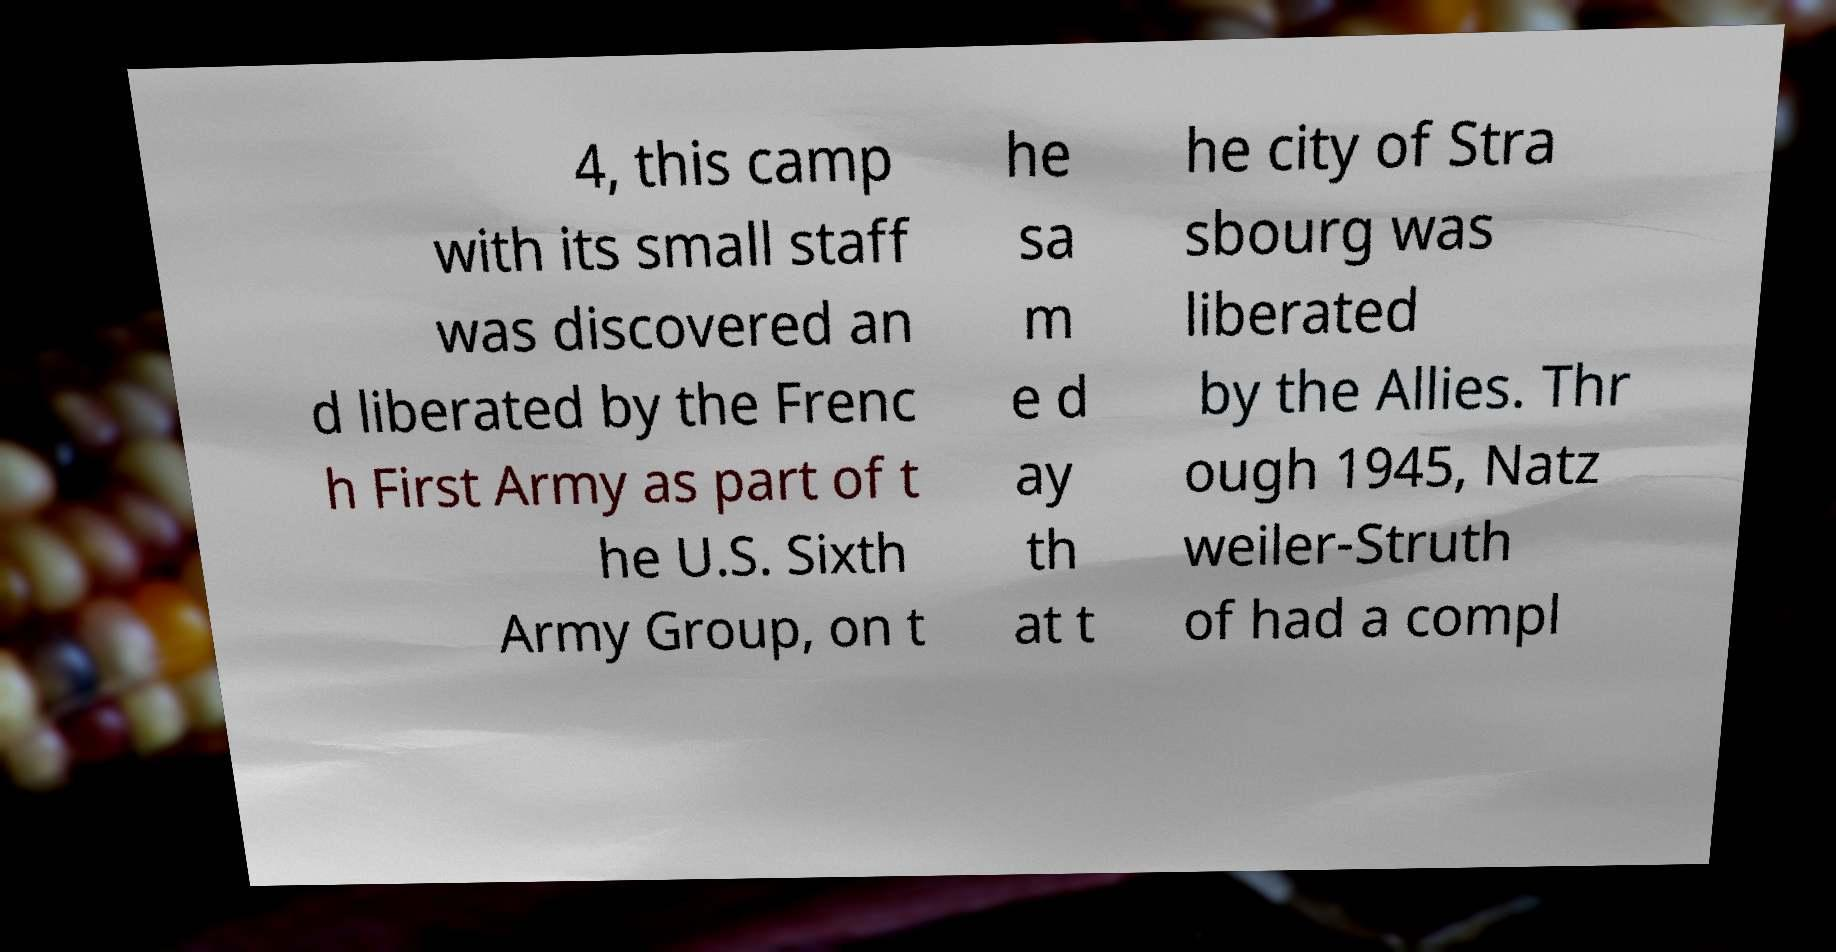Could you extract and type out the text from this image? 4, this camp with its small staff was discovered an d liberated by the Frenc h First Army as part of t he U.S. Sixth Army Group, on t he sa m e d ay th at t he city of Stra sbourg was liberated by the Allies. Thr ough 1945, Natz weiler-Struth of had a compl 